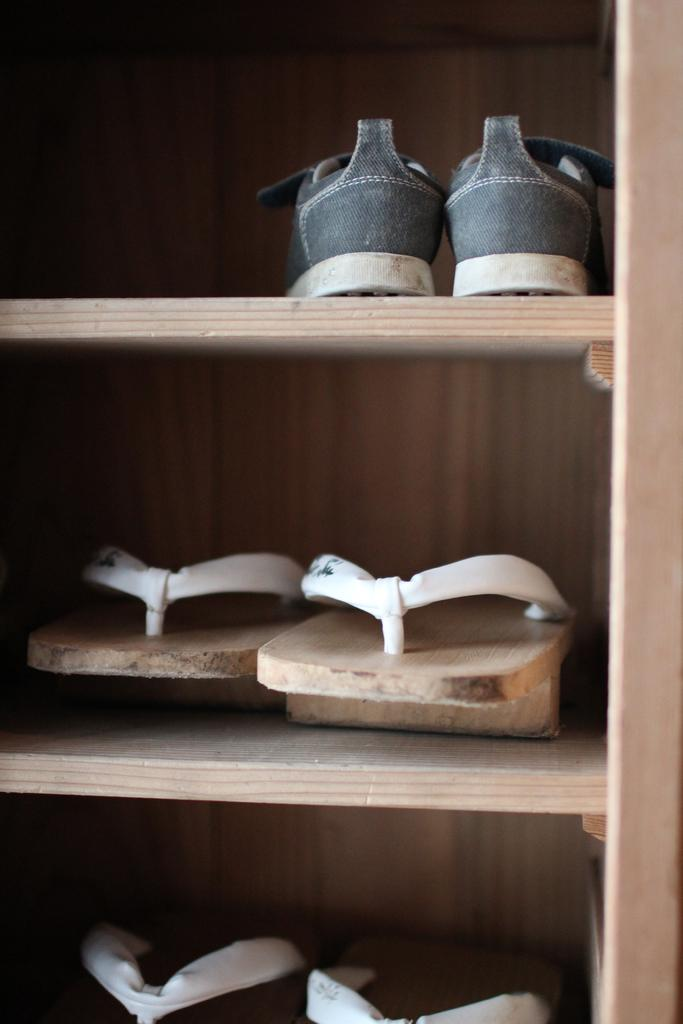What type of storage or display can be seen in the image? There are shelves in the image. What items are stored or displayed on the shelves? The shelves contain footwear. Can you hear the beggar asking for yams in the image? There is no reference to a beggar or yams in the image, so it is not possible to hear any such interaction. 